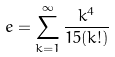<formula> <loc_0><loc_0><loc_500><loc_500>e = \sum _ { k = 1 } ^ { \infty } \frac { k ^ { 4 } } { 1 5 ( k ! ) }</formula> 